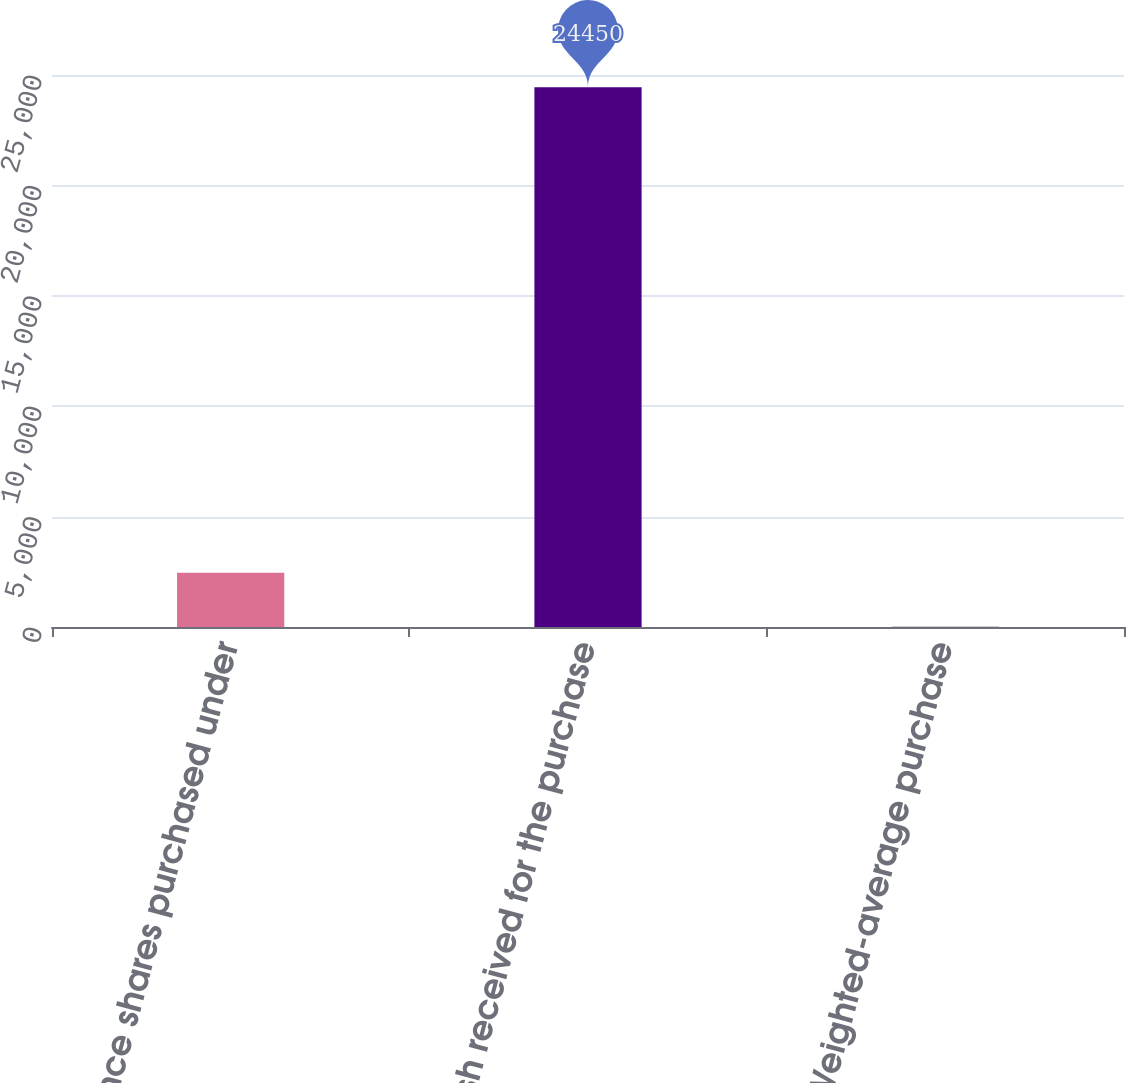Convert chart to OTSL. <chart><loc_0><loc_0><loc_500><loc_500><bar_chart><fcel>Cadence shares purchased under<fcel>Cash received for the purchase<fcel>Weighted-average purchase<nl><fcel>2459.96<fcel>24450<fcel>16.62<nl></chart> 